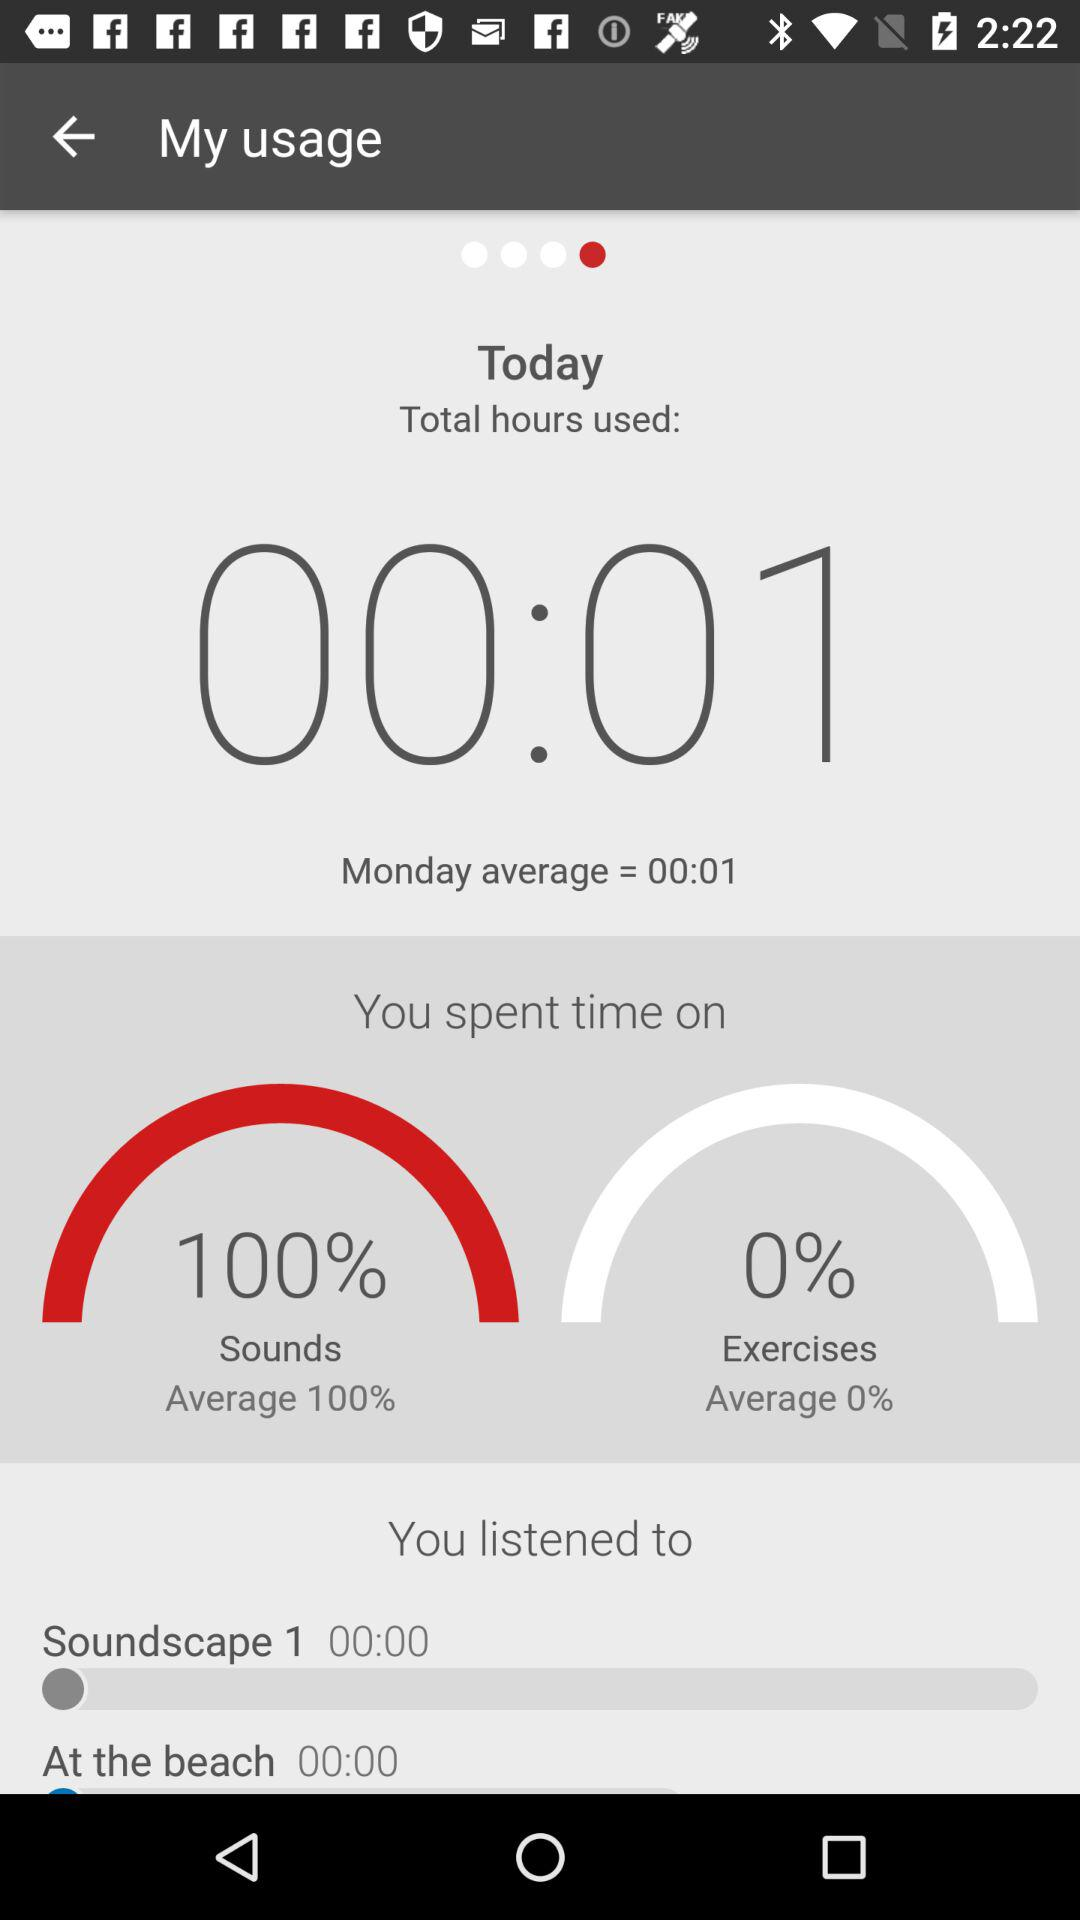What's the name of the sound listened? The names of the sounds listened are "Soundscape 1" and "At the beach ". 